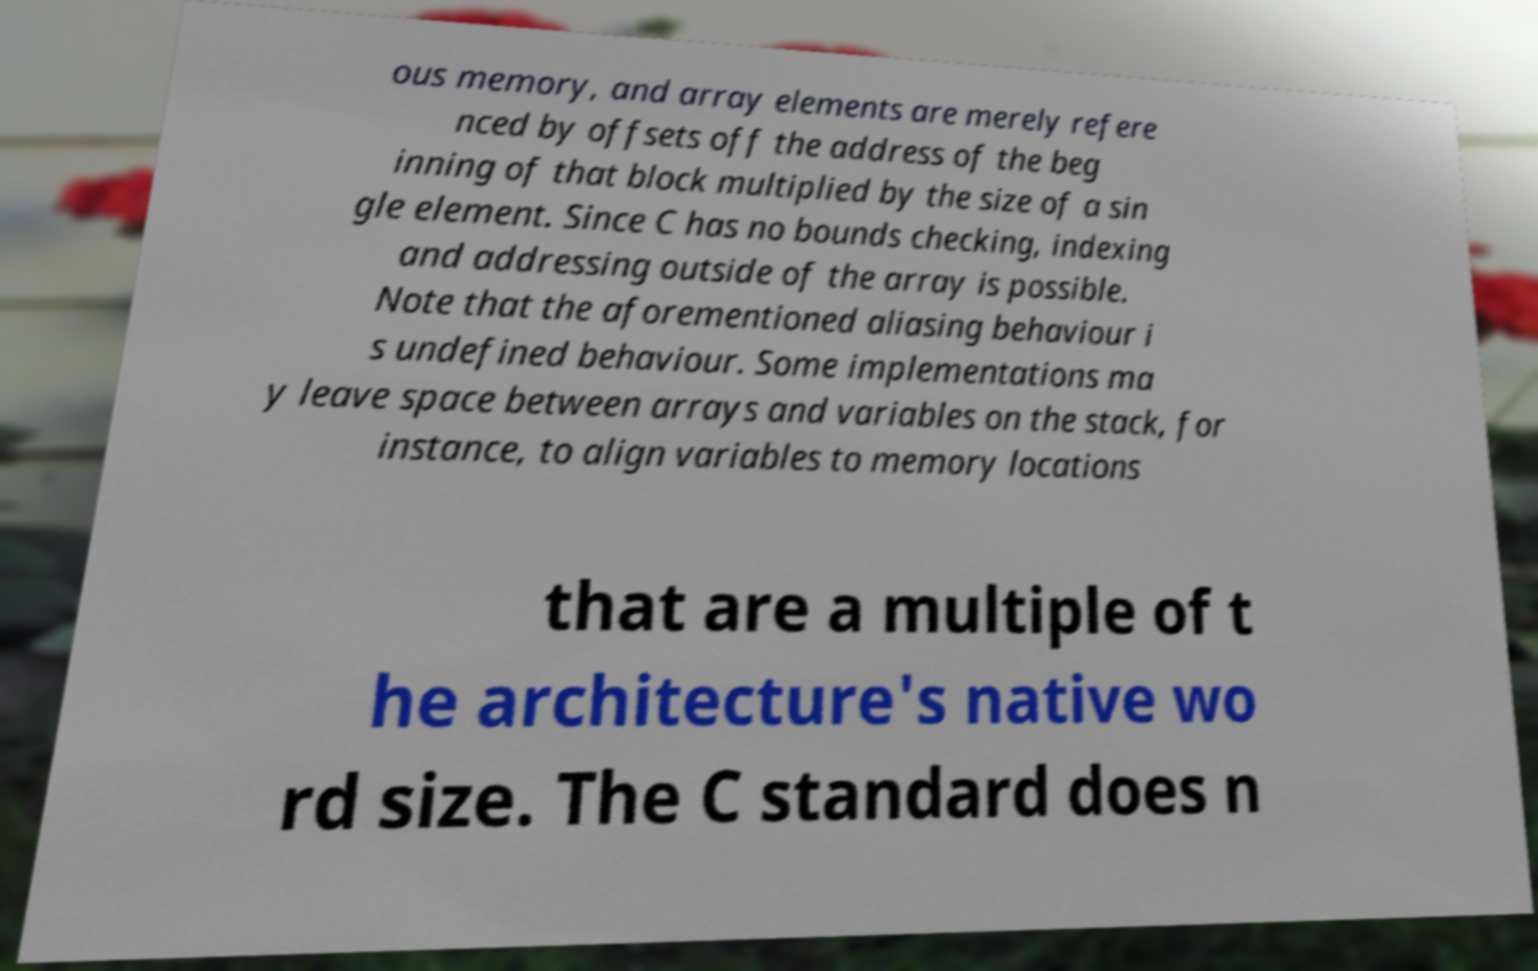Can you read and provide the text displayed in the image?This photo seems to have some interesting text. Can you extract and type it out for me? ous memory, and array elements are merely refere nced by offsets off the address of the beg inning of that block multiplied by the size of a sin gle element. Since C has no bounds checking, indexing and addressing outside of the array is possible. Note that the aforementioned aliasing behaviour i s undefined behaviour. Some implementations ma y leave space between arrays and variables on the stack, for instance, to align variables to memory locations that are a multiple of t he architecture's native wo rd size. The C standard does n 